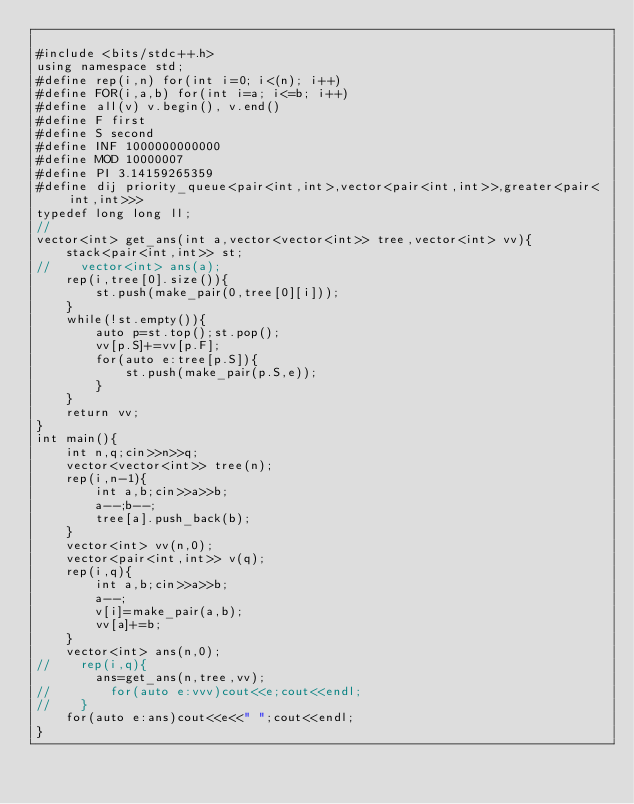Convert code to text. <code><loc_0><loc_0><loc_500><loc_500><_C++_>
#include <bits/stdc++.h>
using namespace std;
#define rep(i,n) for(int i=0; i<(n); i++)
#define FOR(i,a,b) for(int i=a; i<=b; i++)
#define all(v) v.begin(), v.end()
#define F first
#define S second
#define INF 1000000000000
#define MOD 10000007
#define PI 3.14159265359
#define dij priority_queue<pair<int,int>,vector<pair<int,int>>,greater<pair<int,int>>>
typedef long long ll;
//
vector<int> get_ans(int a,vector<vector<int>> tree,vector<int> vv){
    stack<pair<int,int>> st;
//    vector<int> ans(a);
    rep(i,tree[0].size()){
        st.push(make_pair(0,tree[0][i]));
    }
    while(!st.empty()){
        auto p=st.top();st.pop();
        vv[p.S]+=vv[p.F]; 
        for(auto e:tree[p.S]){
            st.push(make_pair(p.S,e));
        }
    }
    return vv;
}
int main(){
    int n,q;cin>>n>>q;
    vector<vector<int>> tree(n);
    rep(i,n-1){
        int a,b;cin>>a>>b;
        a--;b--;
        tree[a].push_back(b);
    }
    vector<int> vv(n,0);
    vector<pair<int,int>> v(q);
    rep(i,q){
        int a,b;cin>>a>>b;
        a--;
        v[i]=make_pair(a,b);
        vv[a]+=b;
    }
    vector<int> ans(n,0);
//    rep(i,q){
        ans=get_ans(n,tree,vv);
//        for(auto e:vvv)cout<<e;cout<<endl;
//    }
    for(auto e:ans)cout<<e<<" ";cout<<endl;
}
</code> 